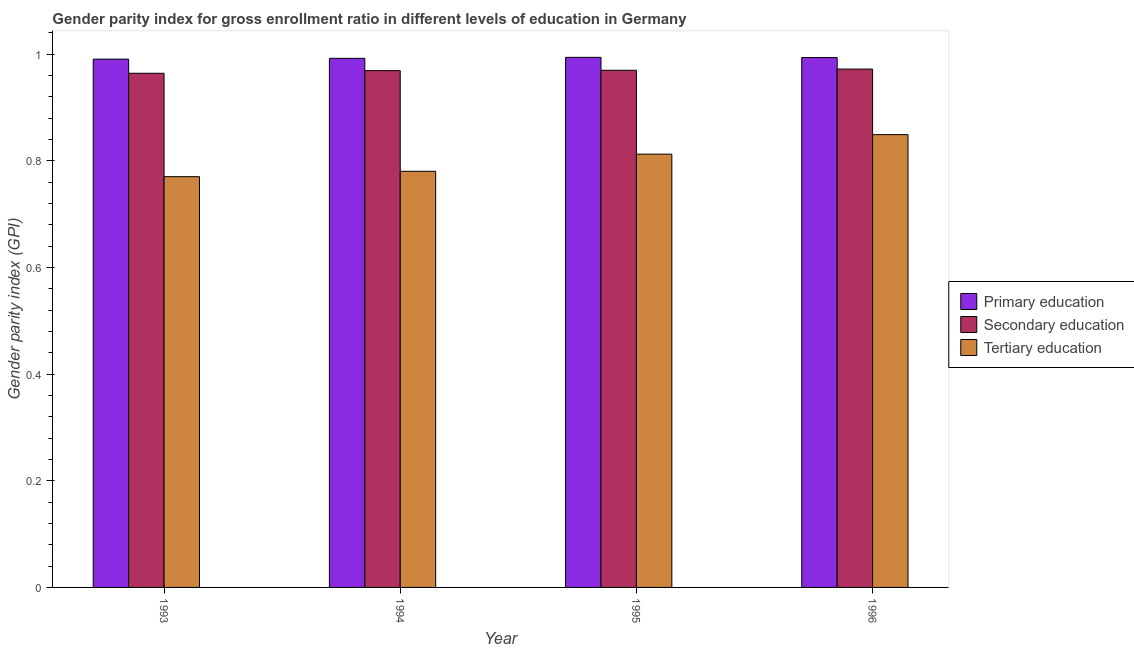How many different coloured bars are there?
Offer a terse response. 3. How many groups of bars are there?
Make the answer very short. 4. Are the number of bars per tick equal to the number of legend labels?
Offer a terse response. Yes. How many bars are there on the 3rd tick from the left?
Provide a short and direct response. 3. How many bars are there on the 1st tick from the right?
Give a very brief answer. 3. What is the gender parity index in primary education in 1996?
Provide a short and direct response. 0.99. Across all years, what is the maximum gender parity index in secondary education?
Offer a very short reply. 0.97. Across all years, what is the minimum gender parity index in primary education?
Offer a terse response. 0.99. In which year was the gender parity index in tertiary education maximum?
Keep it short and to the point. 1996. In which year was the gender parity index in secondary education minimum?
Your response must be concise. 1993. What is the total gender parity index in tertiary education in the graph?
Keep it short and to the point. 3.21. What is the difference between the gender parity index in tertiary education in 1993 and that in 1996?
Ensure brevity in your answer.  -0.08. What is the difference between the gender parity index in primary education in 1996 and the gender parity index in tertiary education in 1993?
Give a very brief answer. 0. What is the average gender parity index in secondary education per year?
Ensure brevity in your answer.  0.97. In the year 1995, what is the difference between the gender parity index in tertiary education and gender parity index in primary education?
Your answer should be compact. 0. In how many years, is the gender parity index in primary education greater than 0.32?
Make the answer very short. 4. What is the ratio of the gender parity index in primary education in 1995 to that in 1996?
Offer a terse response. 1. What is the difference between the highest and the second highest gender parity index in primary education?
Offer a terse response. 0. What is the difference between the highest and the lowest gender parity index in primary education?
Your answer should be very brief. 0. In how many years, is the gender parity index in secondary education greater than the average gender parity index in secondary education taken over all years?
Your answer should be very brief. 3. What does the 1st bar from the right in 1996 represents?
Make the answer very short. Tertiary education. How many bars are there?
Make the answer very short. 12. How many years are there in the graph?
Offer a terse response. 4. What is the difference between two consecutive major ticks on the Y-axis?
Your answer should be compact. 0.2. How many legend labels are there?
Keep it short and to the point. 3. How are the legend labels stacked?
Offer a very short reply. Vertical. What is the title of the graph?
Make the answer very short. Gender parity index for gross enrollment ratio in different levels of education in Germany. What is the label or title of the X-axis?
Keep it short and to the point. Year. What is the label or title of the Y-axis?
Your answer should be very brief. Gender parity index (GPI). What is the Gender parity index (GPI) in Primary education in 1993?
Offer a very short reply. 0.99. What is the Gender parity index (GPI) in Secondary education in 1993?
Your answer should be very brief. 0.96. What is the Gender parity index (GPI) in Tertiary education in 1993?
Keep it short and to the point. 0.77. What is the Gender parity index (GPI) in Primary education in 1994?
Make the answer very short. 0.99. What is the Gender parity index (GPI) of Secondary education in 1994?
Provide a short and direct response. 0.97. What is the Gender parity index (GPI) in Tertiary education in 1994?
Give a very brief answer. 0.78. What is the Gender parity index (GPI) in Primary education in 1995?
Provide a short and direct response. 0.99. What is the Gender parity index (GPI) of Secondary education in 1995?
Ensure brevity in your answer.  0.97. What is the Gender parity index (GPI) of Tertiary education in 1995?
Your answer should be very brief. 0.81. What is the Gender parity index (GPI) in Primary education in 1996?
Make the answer very short. 0.99. What is the Gender parity index (GPI) in Secondary education in 1996?
Your response must be concise. 0.97. What is the Gender parity index (GPI) of Tertiary education in 1996?
Provide a succinct answer. 0.85. Across all years, what is the maximum Gender parity index (GPI) of Primary education?
Keep it short and to the point. 0.99. Across all years, what is the maximum Gender parity index (GPI) of Secondary education?
Give a very brief answer. 0.97. Across all years, what is the maximum Gender parity index (GPI) in Tertiary education?
Provide a short and direct response. 0.85. Across all years, what is the minimum Gender parity index (GPI) in Primary education?
Your answer should be very brief. 0.99. Across all years, what is the minimum Gender parity index (GPI) in Secondary education?
Give a very brief answer. 0.96. Across all years, what is the minimum Gender parity index (GPI) of Tertiary education?
Provide a short and direct response. 0.77. What is the total Gender parity index (GPI) in Primary education in the graph?
Give a very brief answer. 3.97. What is the total Gender parity index (GPI) of Secondary education in the graph?
Make the answer very short. 3.88. What is the total Gender parity index (GPI) in Tertiary education in the graph?
Give a very brief answer. 3.21. What is the difference between the Gender parity index (GPI) in Primary education in 1993 and that in 1994?
Offer a terse response. -0. What is the difference between the Gender parity index (GPI) of Secondary education in 1993 and that in 1994?
Ensure brevity in your answer.  -0. What is the difference between the Gender parity index (GPI) of Tertiary education in 1993 and that in 1994?
Ensure brevity in your answer.  -0.01. What is the difference between the Gender parity index (GPI) of Primary education in 1993 and that in 1995?
Offer a very short reply. -0. What is the difference between the Gender parity index (GPI) of Secondary education in 1993 and that in 1995?
Your answer should be very brief. -0.01. What is the difference between the Gender parity index (GPI) in Tertiary education in 1993 and that in 1995?
Your answer should be very brief. -0.04. What is the difference between the Gender parity index (GPI) in Primary education in 1993 and that in 1996?
Ensure brevity in your answer.  -0. What is the difference between the Gender parity index (GPI) of Secondary education in 1993 and that in 1996?
Make the answer very short. -0.01. What is the difference between the Gender parity index (GPI) in Tertiary education in 1993 and that in 1996?
Offer a very short reply. -0.08. What is the difference between the Gender parity index (GPI) of Primary education in 1994 and that in 1995?
Your answer should be compact. -0. What is the difference between the Gender parity index (GPI) of Secondary education in 1994 and that in 1995?
Provide a short and direct response. -0. What is the difference between the Gender parity index (GPI) of Tertiary education in 1994 and that in 1995?
Make the answer very short. -0.03. What is the difference between the Gender parity index (GPI) of Primary education in 1994 and that in 1996?
Offer a very short reply. -0. What is the difference between the Gender parity index (GPI) in Secondary education in 1994 and that in 1996?
Ensure brevity in your answer.  -0. What is the difference between the Gender parity index (GPI) in Tertiary education in 1994 and that in 1996?
Provide a succinct answer. -0.07. What is the difference between the Gender parity index (GPI) in Primary education in 1995 and that in 1996?
Your response must be concise. 0. What is the difference between the Gender parity index (GPI) in Secondary education in 1995 and that in 1996?
Provide a short and direct response. -0. What is the difference between the Gender parity index (GPI) in Tertiary education in 1995 and that in 1996?
Make the answer very short. -0.04. What is the difference between the Gender parity index (GPI) in Primary education in 1993 and the Gender parity index (GPI) in Secondary education in 1994?
Provide a succinct answer. 0.02. What is the difference between the Gender parity index (GPI) of Primary education in 1993 and the Gender parity index (GPI) of Tertiary education in 1994?
Make the answer very short. 0.21. What is the difference between the Gender parity index (GPI) in Secondary education in 1993 and the Gender parity index (GPI) in Tertiary education in 1994?
Your response must be concise. 0.18. What is the difference between the Gender parity index (GPI) of Primary education in 1993 and the Gender parity index (GPI) of Secondary education in 1995?
Offer a terse response. 0.02. What is the difference between the Gender parity index (GPI) in Primary education in 1993 and the Gender parity index (GPI) in Tertiary education in 1995?
Keep it short and to the point. 0.18. What is the difference between the Gender parity index (GPI) in Secondary education in 1993 and the Gender parity index (GPI) in Tertiary education in 1995?
Offer a terse response. 0.15. What is the difference between the Gender parity index (GPI) of Primary education in 1993 and the Gender parity index (GPI) of Secondary education in 1996?
Give a very brief answer. 0.02. What is the difference between the Gender parity index (GPI) in Primary education in 1993 and the Gender parity index (GPI) in Tertiary education in 1996?
Your answer should be compact. 0.14. What is the difference between the Gender parity index (GPI) of Secondary education in 1993 and the Gender parity index (GPI) of Tertiary education in 1996?
Provide a short and direct response. 0.12. What is the difference between the Gender parity index (GPI) of Primary education in 1994 and the Gender parity index (GPI) of Secondary education in 1995?
Provide a succinct answer. 0.02. What is the difference between the Gender parity index (GPI) of Primary education in 1994 and the Gender parity index (GPI) of Tertiary education in 1995?
Your response must be concise. 0.18. What is the difference between the Gender parity index (GPI) of Secondary education in 1994 and the Gender parity index (GPI) of Tertiary education in 1995?
Your answer should be compact. 0.16. What is the difference between the Gender parity index (GPI) of Primary education in 1994 and the Gender parity index (GPI) of Secondary education in 1996?
Ensure brevity in your answer.  0.02. What is the difference between the Gender parity index (GPI) in Primary education in 1994 and the Gender parity index (GPI) in Tertiary education in 1996?
Your answer should be very brief. 0.14. What is the difference between the Gender parity index (GPI) of Secondary education in 1994 and the Gender parity index (GPI) of Tertiary education in 1996?
Offer a very short reply. 0.12. What is the difference between the Gender parity index (GPI) of Primary education in 1995 and the Gender parity index (GPI) of Secondary education in 1996?
Offer a very short reply. 0.02. What is the difference between the Gender parity index (GPI) in Primary education in 1995 and the Gender parity index (GPI) in Tertiary education in 1996?
Give a very brief answer. 0.14. What is the difference between the Gender parity index (GPI) of Secondary education in 1995 and the Gender parity index (GPI) of Tertiary education in 1996?
Give a very brief answer. 0.12. What is the average Gender parity index (GPI) in Primary education per year?
Provide a short and direct response. 0.99. What is the average Gender parity index (GPI) of Secondary education per year?
Make the answer very short. 0.97. What is the average Gender parity index (GPI) in Tertiary education per year?
Your answer should be compact. 0.8. In the year 1993, what is the difference between the Gender parity index (GPI) in Primary education and Gender parity index (GPI) in Secondary education?
Give a very brief answer. 0.03. In the year 1993, what is the difference between the Gender parity index (GPI) in Primary education and Gender parity index (GPI) in Tertiary education?
Provide a succinct answer. 0.22. In the year 1993, what is the difference between the Gender parity index (GPI) of Secondary education and Gender parity index (GPI) of Tertiary education?
Provide a short and direct response. 0.19. In the year 1994, what is the difference between the Gender parity index (GPI) of Primary education and Gender parity index (GPI) of Secondary education?
Provide a short and direct response. 0.02. In the year 1994, what is the difference between the Gender parity index (GPI) of Primary education and Gender parity index (GPI) of Tertiary education?
Your response must be concise. 0.21. In the year 1994, what is the difference between the Gender parity index (GPI) of Secondary education and Gender parity index (GPI) of Tertiary education?
Your response must be concise. 0.19. In the year 1995, what is the difference between the Gender parity index (GPI) in Primary education and Gender parity index (GPI) in Secondary education?
Offer a terse response. 0.02. In the year 1995, what is the difference between the Gender parity index (GPI) in Primary education and Gender parity index (GPI) in Tertiary education?
Your answer should be compact. 0.18. In the year 1995, what is the difference between the Gender parity index (GPI) in Secondary education and Gender parity index (GPI) in Tertiary education?
Your answer should be compact. 0.16. In the year 1996, what is the difference between the Gender parity index (GPI) in Primary education and Gender parity index (GPI) in Secondary education?
Offer a very short reply. 0.02. In the year 1996, what is the difference between the Gender parity index (GPI) in Primary education and Gender parity index (GPI) in Tertiary education?
Ensure brevity in your answer.  0.14. In the year 1996, what is the difference between the Gender parity index (GPI) of Secondary education and Gender parity index (GPI) of Tertiary education?
Your answer should be very brief. 0.12. What is the ratio of the Gender parity index (GPI) of Secondary education in 1993 to that in 1994?
Your answer should be compact. 0.99. What is the ratio of the Gender parity index (GPI) of Tertiary education in 1993 to that in 1994?
Offer a very short reply. 0.99. What is the ratio of the Gender parity index (GPI) in Primary education in 1993 to that in 1995?
Your answer should be very brief. 1. What is the ratio of the Gender parity index (GPI) of Secondary education in 1993 to that in 1995?
Your answer should be compact. 0.99. What is the ratio of the Gender parity index (GPI) in Tertiary education in 1993 to that in 1995?
Offer a very short reply. 0.95. What is the ratio of the Gender parity index (GPI) of Primary education in 1993 to that in 1996?
Offer a very short reply. 1. What is the ratio of the Gender parity index (GPI) of Tertiary education in 1993 to that in 1996?
Your answer should be compact. 0.91. What is the ratio of the Gender parity index (GPI) in Tertiary education in 1994 to that in 1995?
Your answer should be very brief. 0.96. What is the ratio of the Gender parity index (GPI) of Secondary education in 1994 to that in 1996?
Provide a short and direct response. 1. What is the ratio of the Gender parity index (GPI) of Tertiary education in 1994 to that in 1996?
Ensure brevity in your answer.  0.92. What is the ratio of the Gender parity index (GPI) in Primary education in 1995 to that in 1996?
Provide a succinct answer. 1. What is the ratio of the Gender parity index (GPI) in Secondary education in 1995 to that in 1996?
Provide a short and direct response. 1. What is the ratio of the Gender parity index (GPI) of Tertiary education in 1995 to that in 1996?
Offer a very short reply. 0.96. What is the difference between the highest and the second highest Gender parity index (GPI) in Secondary education?
Make the answer very short. 0. What is the difference between the highest and the second highest Gender parity index (GPI) in Tertiary education?
Make the answer very short. 0.04. What is the difference between the highest and the lowest Gender parity index (GPI) in Primary education?
Provide a succinct answer. 0. What is the difference between the highest and the lowest Gender parity index (GPI) of Secondary education?
Your answer should be compact. 0.01. What is the difference between the highest and the lowest Gender parity index (GPI) in Tertiary education?
Provide a succinct answer. 0.08. 